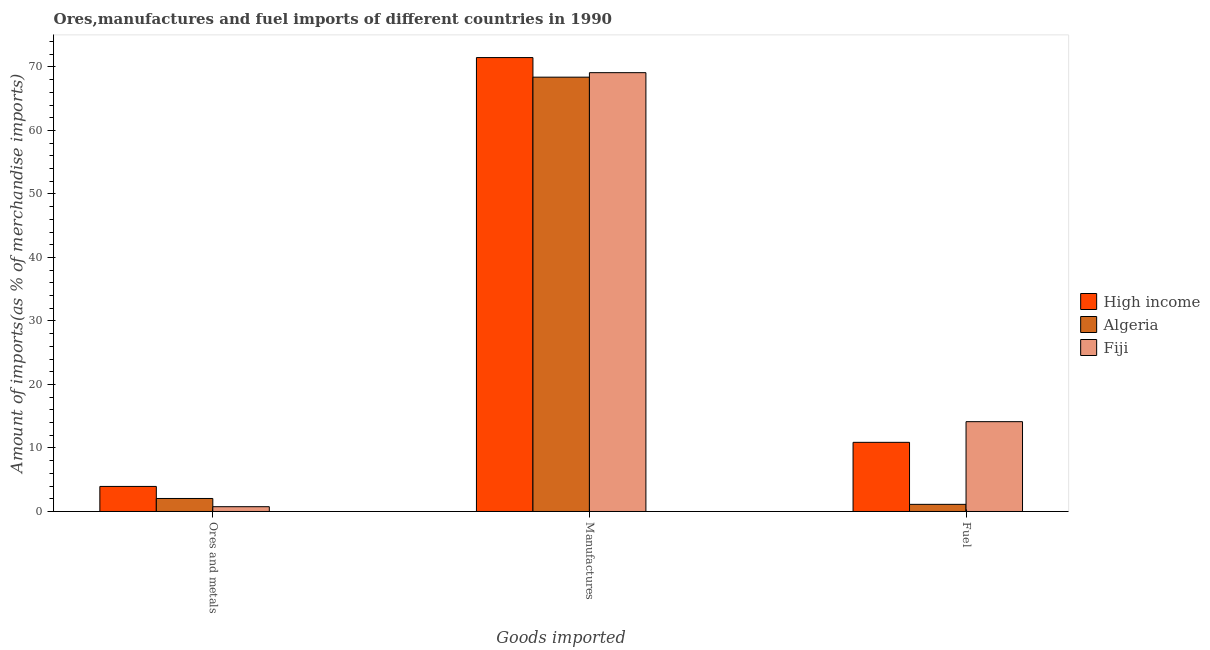How many groups of bars are there?
Keep it short and to the point. 3. Are the number of bars per tick equal to the number of legend labels?
Offer a terse response. Yes. How many bars are there on the 3rd tick from the right?
Keep it short and to the point. 3. What is the label of the 3rd group of bars from the left?
Your answer should be compact. Fuel. What is the percentage of ores and metals imports in High income?
Your answer should be compact. 3.95. Across all countries, what is the maximum percentage of ores and metals imports?
Make the answer very short. 3.95. Across all countries, what is the minimum percentage of manufactures imports?
Offer a terse response. 68.4. In which country was the percentage of fuel imports maximum?
Offer a terse response. Fiji. In which country was the percentage of fuel imports minimum?
Give a very brief answer. Algeria. What is the total percentage of ores and metals imports in the graph?
Your answer should be compact. 6.75. What is the difference between the percentage of fuel imports in Fiji and that in Algeria?
Provide a short and direct response. 13.02. What is the difference between the percentage of ores and metals imports in Algeria and the percentage of manufactures imports in High income?
Keep it short and to the point. -69.43. What is the average percentage of ores and metals imports per country?
Provide a succinct answer. 2.25. What is the difference between the percentage of manufactures imports and percentage of fuel imports in Fiji?
Make the answer very short. 54.96. What is the ratio of the percentage of ores and metals imports in Fiji to that in Algeria?
Ensure brevity in your answer.  0.37. Is the difference between the percentage of ores and metals imports in Algeria and High income greater than the difference between the percentage of manufactures imports in Algeria and High income?
Give a very brief answer. Yes. What is the difference between the highest and the second highest percentage of ores and metals imports?
Offer a terse response. 1.9. What is the difference between the highest and the lowest percentage of ores and metals imports?
Your answer should be very brief. 3.19. What does the 2nd bar from the left in Ores and metals represents?
Your response must be concise. Algeria. Is it the case that in every country, the sum of the percentage of ores and metals imports and percentage of manufactures imports is greater than the percentage of fuel imports?
Provide a succinct answer. Yes. How many bars are there?
Your answer should be compact. 9. Are all the bars in the graph horizontal?
Give a very brief answer. No. How many countries are there in the graph?
Provide a short and direct response. 3. What is the difference between two consecutive major ticks on the Y-axis?
Offer a very short reply. 10. Does the graph contain any zero values?
Make the answer very short. No. Does the graph contain grids?
Provide a short and direct response. No. Where does the legend appear in the graph?
Provide a succinct answer. Center right. How are the legend labels stacked?
Provide a short and direct response. Vertical. What is the title of the graph?
Provide a short and direct response. Ores,manufactures and fuel imports of different countries in 1990. What is the label or title of the X-axis?
Provide a short and direct response. Goods imported. What is the label or title of the Y-axis?
Keep it short and to the point. Amount of imports(as % of merchandise imports). What is the Amount of imports(as % of merchandise imports) of High income in Ores and metals?
Give a very brief answer. 3.95. What is the Amount of imports(as % of merchandise imports) in Algeria in Ores and metals?
Your answer should be compact. 2.05. What is the Amount of imports(as % of merchandise imports) in Fiji in Ores and metals?
Provide a short and direct response. 0.75. What is the Amount of imports(as % of merchandise imports) of High income in Manufactures?
Offer a terse response. 71.48. What is the Amount of imports(as % of merchandise imports) of Algeria in Manufactures?
Ensure brevity in your answer.  68.4. What is the Amount of imports(as % of merchandise imports) of Fiji in Manufactures?
Provide a short and direct response. 69.11. What is the Amount of imports(as % of merchandise imports) in High income in Fuel?
Provide a short and direct response. 10.89. What is the Amount of imports(as % of merchandise imports) of Algeria in Fuel?
Provide a short and direct response. 1.12. What is the Amount of imports(as % of merchandise imports) of Fiji in Fuel?
Your response must be concise. 14.14. Across all Goods imported, what is the maximum Amount of imports(as % of merchandise imports) of High income?
Your response must be concise. 71.48. Across all Goods imported, what is the maximum Amount of imports(as % of merchandise imports) of Algeria?
Offer a very short reply. 68.4. Across all Goods imported, what is the maximum Amount of imports(as % of merchandise imports) of Fiji?
Offer a terse response. 69.11. Across all Goods imported, what is the minimum Amount of imports(as % of merchandise imports) in High income?
Provide a succinct answer. 3.95. Across all Goods imported, what is the minimum Amount of imports(as % of merchandise imports) in Algeria?
Make the answer very short. 1.12. Across all Goods imported, what is the minimum Amount of imports(as % of merchandise imports) of Fiji?
Ensure brevity in your answer.  0.75. What is the total Amount of imports(as % of merchandise imports) of High income in the graph?
Your response must be concise. 86.32. What is the total Amount of imports(as % of merchandise imports) of Algeria in the graph?
Your answer should be compact. 71.57. What is the total Amount of imports(as % of merchandise imports) of Fiji in the graph?
Keep it short and to the point. 84. What is the difference between the Amount of imports(as % of merchandise imports) of High income in Ores and metals and that in Manufactures?
Offer a terse response. -67.54. What is the difference between the Amount of imports(as % of merchandise imports) of Algeria in Ores and metals and that in Manufactures?
Offer a terse response. -66.35. What is the difference between the Amount of imports(as % of merchandise imports) of Fiji in Ores and metals and that in Manufactures?
Your answer should be compact. -68.35. What is the difference between the Amount of imports(as % of merchandise imports) of High income in Ores and metals and that in Fuel?
Give a very brief answer. -6.94. What is the difference between the Amount of imports(as % of merchandise imports) of Algeria in Ores and metals and that in Fuel?
Provide a short and direct response. 0.93. What is the difference between the Amount of imports(as % of merchandise imports) of Fiji in Ores and metals and that in Fuel?
Provide a succinct answer. -13.39. What is the difference between the Amount of imports(as % of merchandise imports) of High income in Manufactures and that in Fuel?
Your answer should be very brief. 60.59. What is the difference between the Amount of imports(as % of merchandise imports) of Algeria in Manufactures and that in Fuel?
Your answer should be very brief. 67.27. What is the difference between the Amount of imports(as % of merchandise imports) in Fiji in Manufactures and that in Fuel?
Provide a short and direct response. 54.96. What is the difference between the Amount of imports(as % of merchandise imports) in High income in Ores and metals and the Amount of imports(as % of merchandise imports) in Algeria in Manufactures?
Your response must be concise. -64.45. What is the difference between the Amount of imports(as % of merchandise imports) in High income in Ores and metals and the Amount of imports(as % of merchandise imports) in Fiji in Manufactures?
Offer a terse response. -65.16. What is the difference between the Amount of imports(as % of merchandise imports) of Algeria in Ores and metals and the Amount of imports(as % of merchandise imports) of Fiji in Manufactures?
Your answer should be very brief. -67.06. What is the difference between the Amount of imports(as % of merchandise imports) in High income in Ores and metals and the Amount of imports(as % of merchandise imports) in Algeria in Fuel?
Provide a short and direct response. 2.82. What is the difference between the Amount of imports(as % of merchandise imports) in High income in Ores and metals and the Amount of imports(as % of merchandise imports) in Fiji in Fuel?
Give a very brief answer. -10.2. What is the difference between the Amount of imports(as % of merchandise imports) of Algeria in Ores and metals and the Amount of imports(as % of merchandise imports) of Fiji in Fuel?
Provide a succinct answer. -12.09. What is the difference between the Amount of imports(as % of merchandise imports) of High income in Manufactures and the Amount of imports(as % of merchandise imports) of Algeria in Fuel?
Offer a very short reply. 70.36. What is the difference between the Amount of imports(as % of merchandise imports) in High income in Manufactures and the Amount of imports(as % of merchandise imports) in Fiji in Fuel?
Give a very brief answer. 57.34. What is the difference between the Amount of imports(as % of merchandise imports) in Algeria in Manufactures and the Amount of imports(as % of merchandise imports) in Fiji in Fuel?
Offer a terse response. 54.25. What is the average Amount of imports(as % of merchandise imports) of High income per Goods imported?
Offer a very short reply. 28.77. What is the average Amount of imports(as % of merchandise imports) of Algeria per Goods imported?
Provide a succinct answer. 23.86. What is the average Amount of imports(as % of merchandise imports) of Fiji per Goods imported?
Your answer should be very brief. 28. What is the difference between the Amount of imports(as % of merchandise imports) of High income and Amount of imports(as % of merchandise imports) of Algeria in Ores and metals?
Provide a succinct answer. 1.9. What is the difference between the Amount of imports(as % of merchandise imports) of High income and Amount of imports(as % of merchandise imports) of Fiji in Ores and metals?
Provide a succinct answer. 3.19. What is the difference between the Amount of imports(as % of merchandise imports) of Algeria and Amount of imports(as % of merchandise imports) of Fiji in Ores and metals?
Provide a succinct answer. 1.3. What is the difference between the Amount of imports(as % of merchandise imports) in High income and Amount of imports(as % of merchandise imports) in Algeria in Manufactures?
Provide a short and direct response. 3.09. What is the difference between the Amount of imports(as % of merchandise imports) of High income and Amount of imports(as % of merchandise imports) of Fiji in Manufactures?
Provide a short and direct response. 2.38. What is the difference between the Amount of imports(as % of merchandise imports) of Algeria and Amount of imports(as % of merchandise imports) of Fiji in Manufactures?
Offer a very short reply. -0.71. What is the difference between the Amount of imports(as % of merchandise imports) in High income and Amount of imports(as % of merchandise imports) in Algeria in Fuel?
Make the answer very short. 9.77. What is the difference between the Amount of imports(as % of merchandise imports) of High income and Amount of imports(as % of merchandise imports) of Fiji in Fuel?
Make the answer very short. -3.25. What is the difference between the Amount of imports(as % of merchandise imports) of Algeria and Amount of imports(as % of merchandise imports) of Fiji in Fuel?
Your answer should be very brief. -13.02. What is the ratio of the Amount of imports(as % of merchandise imports) of High income in Ores and metals to that in Manufactures?
Your answer should be very brief. 0.06. What is the ratio of the Amount of imports(as % of merchandise imports) of Algeria in Ores and metals to that in Manufactures?
Keep it short and to the point. 0.03. What is the ratio of the Amount of imports(as % of merchandise imports) of Fiji in Ores and metals to that in Manufactures?
Offer a very short reply. 0.01. What is the ratio of the Amount of imports(as % of merchandise imports) of High income in Ores and metals to that in Fuel?
Provide a succinct answer. 0.36. What is the ratio of the Amount of imports(as % of merchandise imports) in Algeria in Ores and metals to that in Fuel?
Offer a very short reply. 1.82. What is the ratio of the Amount of imports(as % of merchandise imports) in Fiji in Ores and metals to that in Fuel?
Provide a succinct answer. 0.05. What is the ratio of the Amount of imports(as % of merchandise imports) in High income in Manufactures to that in Fuel?
Offer a terse response. 6.56. What is the ratio of the Amount of imports(as % of merchandise imports) of Algeria in Manufactures to that in Fuel?
Offer a terse response. 60.89. What is the ratio of the Amount of imports(as % of merchandise imports) of Fiji in Manufactures to that in Fuel?
Make the answer very short. 4.89. What is the difference between the highest and the second highest Amount of imports(as % of merchandise imports) of High income?
Ensure brevity in your answer.  60.59. What is the difference between the highest and the second highest Amount of imports(as % of merchandise imports) of Algeria?
Your response must be concise. 66.35. What is the difference between the highest and the second highest Amount of imports(as % of merchandise imports) in Fiji?
Offer a very short reply. 54.96. What is the difference between the highest and the lowest Amount of imports(as % of merchandise imports) of High income?
Provide a short and direct response. 67.54. What is the difference between the highest and the lowest Amount of imports(as % of merchandise imports) of Algeria?
Offer a very short reply. 67.27. What is the difference between the highest and the lowest Amount of imports(as % of merchandise imports) in Fiji?
Offer a very short reply. 68.35. 